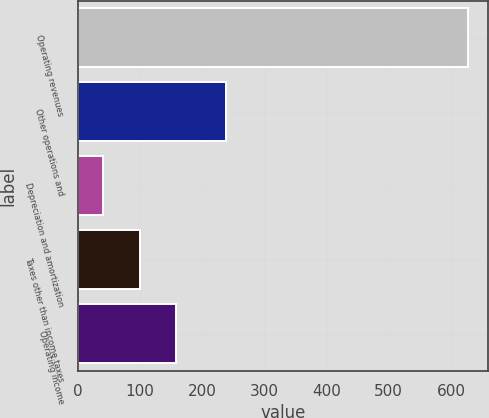<chart> <loc_0><loc_0><loc_500><loc_500><bar_chart><fcel>Operating revenues<fcel>Other operations and<fcel>Depreciation and amortization<fcel>Taxes other than income taxes<fcel>Operating income<nl><fcel>628<fcel>238<fcel>41<fcel>99.7<fcel>158.4<nl></chart> 